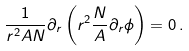<formula> <loc_0><loc_0><loc_500><loc_500>\frac { 1 } { r ^ { 2 } A N } \partial _ { r } \left ( r ^ { 2 } \frac { N } { A } \partial _ { r } \phi \right ) = 0 \, .</formula> 